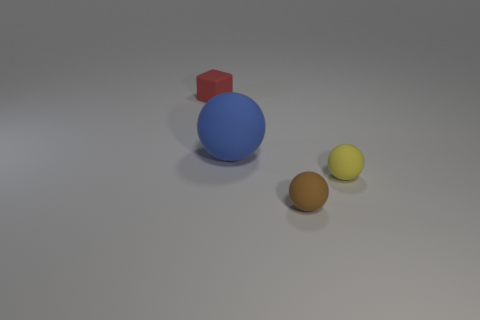Subtract all small yellow rubber balls. How many balls are left? 2 Add 3 small red blocks. How many objects exist? 7 Add 2 red matte cubes. How many red matte cubes are left? 3 Add 2 purple spheres. How many purple spheres exist? 2 Subtract 0 green cylinders. How many objects are left? 4 Subtract all cubes. How many objects are left? 3 Subtract all large red metal cubes. Subtract all rubber objects. How many objects are left? 0 